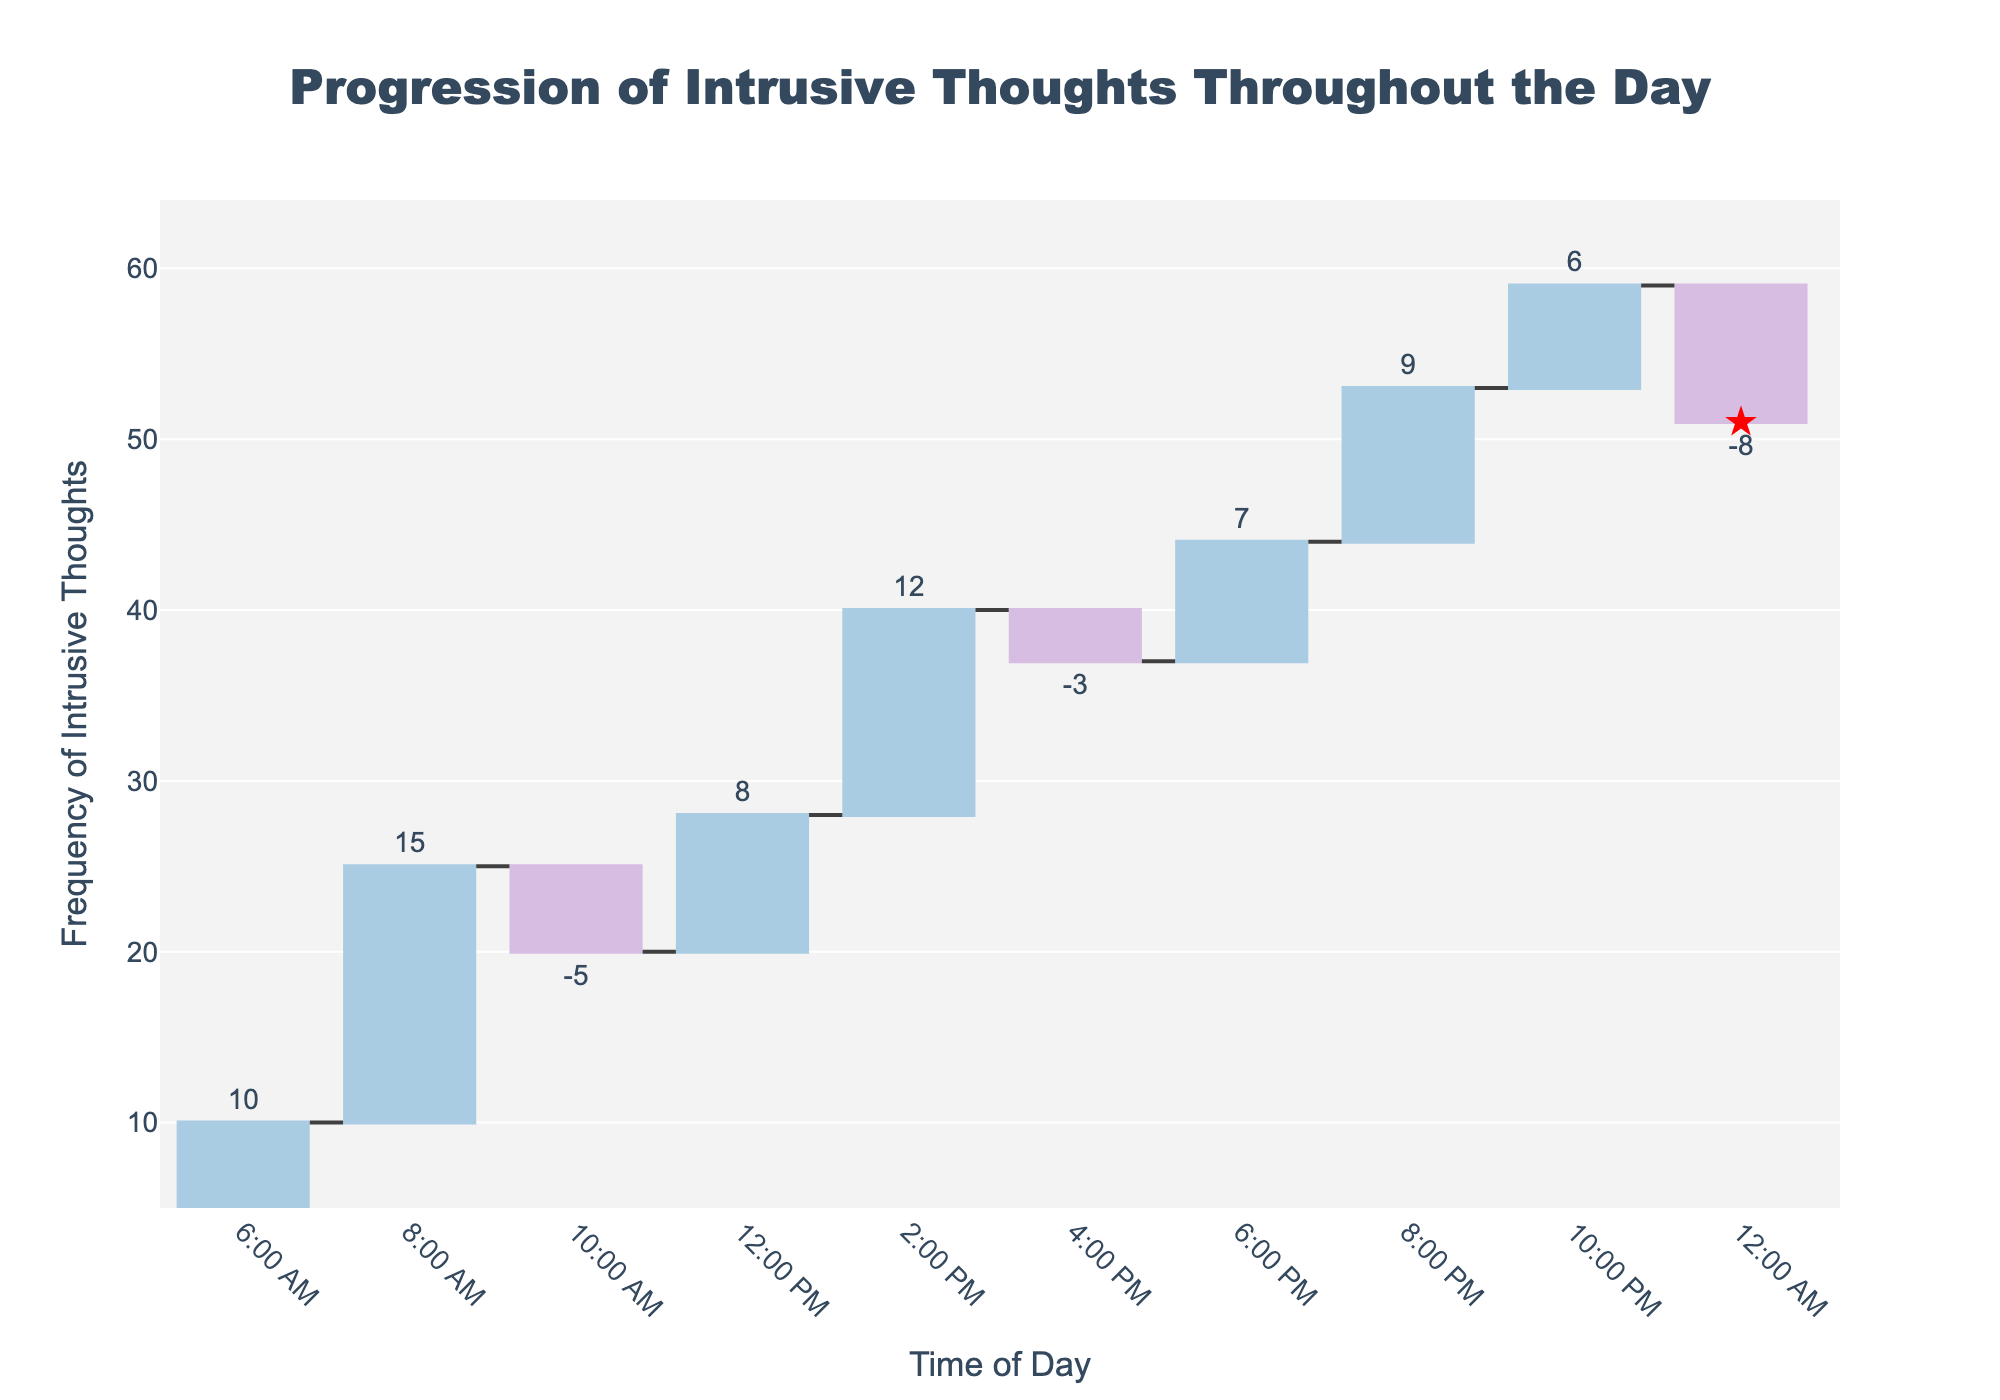What's the title of the figure? The title is displayed at the top center of the figure. The title reads "Progression of Intrusive Thoughts Throughout the Day."
Answer: Progression of Intrusive Thoughts Throughout the Day What time of day has the highest increase in intrusive thoughts? To determine the time with the highest increase, look at the bars that are increasing. The time with the highest increase is the one with the tallest blue bar.
Answer: 8:00 AM Which category has the largest decrease in intrusive thoughts? To find the largest decrease, look for the pink bars since they represent a decrease. The longest pink bar indicates the largest decrease.
Answer: Suicidal ideation How does the frequency of intrusive thoughts at 10:00 PM compare to 12:00 AM? Check the length and position of bars at 10:00 PM and 12:00 AM. The bar at 12:00 AM (Suicidal ideation) shows a decrease, while the one at 10:00 PM (Existential dread) shows an increase.
Answer: 10:00 PM has an increase, 12:00 AM has a decrease What is the cumulative frequency of intrusive thoughts by 8:00 PM? Cumulative frequency refers to the sum of the frequency up to the given time. By 8:00 PM, add up the frequencies at each time point from the start to 8:00 PM.
Answer: 53 What's the overall frequency of intrusive thoughts throughout the day? To find this, sum all the frequencies listed in the dataset.
Answer: 51 Which two times of day have a negative frequency of intrusive thoughts? Look for the bars that extend downward, which indicates a negative value.
Answer: 10:00 AM and 12:00 AM How does the number of categories with an increase in frequency compare to those with a decrease? Count the number of increasing (blue) and decreasing (pink) bars. Compare these counts.
Answer: 7 increases, 3 decreases By how much does the frequency of intrusive thoughts change between 6:00 PM and 8:00 PM? Subtract the frequency at 6:00 PM (7) from the frequency at 8:00 PM (9). Calculate the difference.
Answer: 2 What does the red star symbol represent? The label on the red star symbol indicates the total cumulative frequency of intrusive thoughts at the last time point.
Answer: Total cumulative frequency at the end 